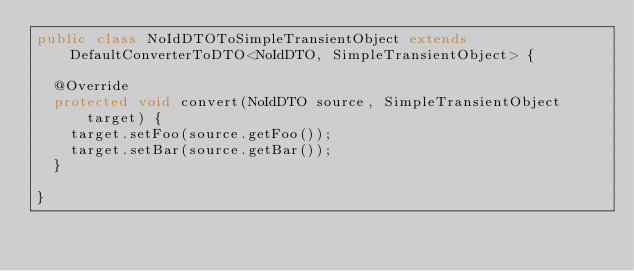<code> <loc_0><loc_0><loc_500><loc_500><_Java_>public class NoIdDTOToSimpleTransientObject extends DefaultConverterToDTO<NoIdDTO, SimpleTransientObject> {

  @Override
  protected void convert(NoIdDTO source, SimpleTransientObject target) {
    target.setFoo(source.getFoo());
    target.setBar(source.getBar());
  }

}
</code> 